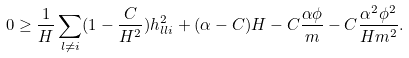<formula> <loc_0><loc_0><loc_500><loc_500>0 \geq \frac { 1 } { H } \sum _ { l \neq i } ( 1 - \frac { C } { H ^ { 2 } } ) h _ { l l i } ^ { 2 } + ( \alpha - C ) H - C \frac { \alpha \phi } { m } - C \frac { \alpha ^ { 2 } \phi ^ { 2 } } { H m ^ { 2 } } .</formula> 